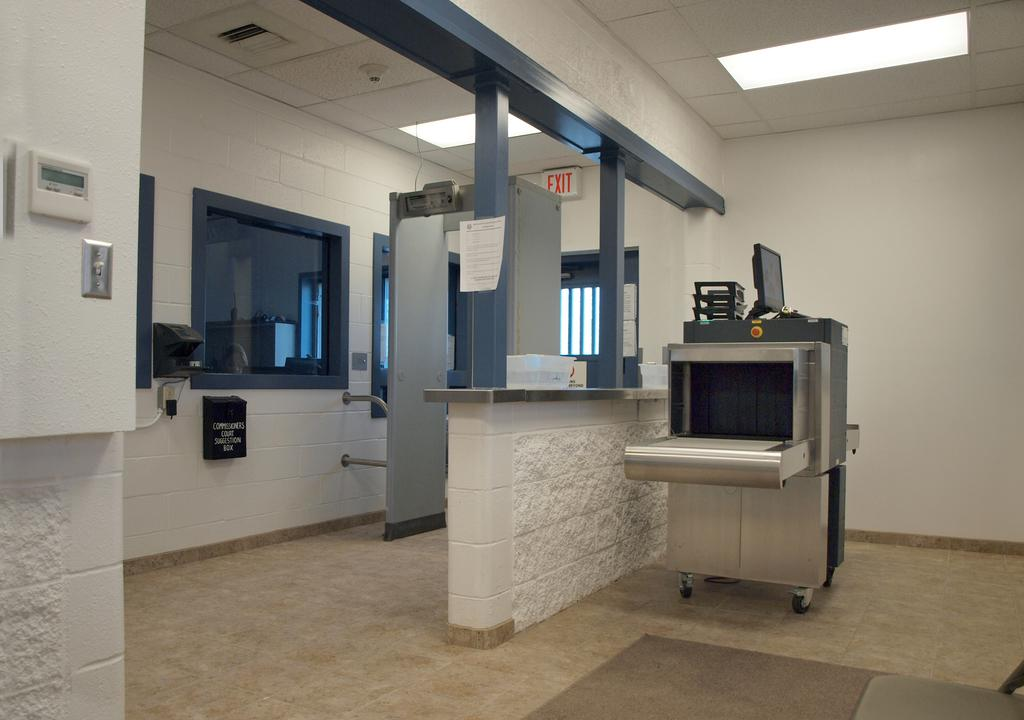<image>
Write a terse but informative summary of the picture. a rather bare office with the word EXIT available in red 